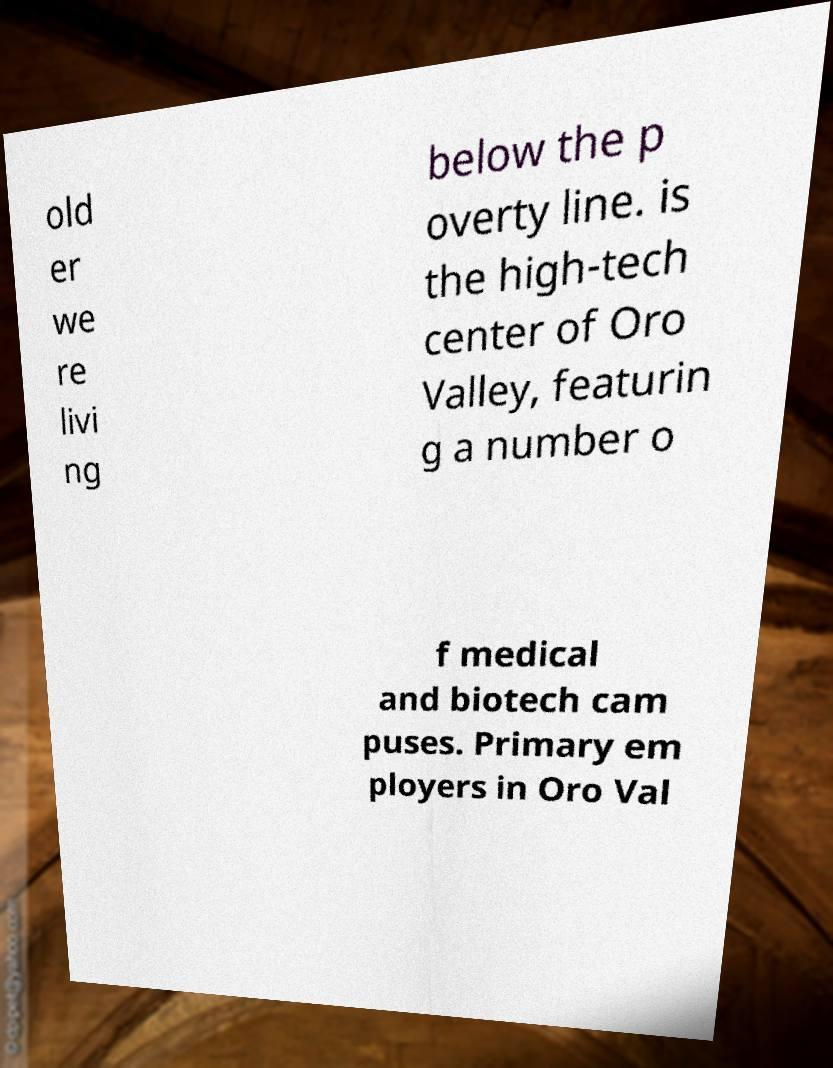There's text embedded in this image that I need extracted. Can you transcribe it verbatim? old er we re livi ng below the p overty line. is the high-tech center of Oro Valley, featurin g a number o f medical and biotech cam puses. Primary em ployers in Oro Val 